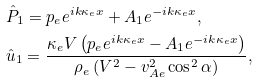<formula> <loc_0><loc_0><loc_500><loc_500>& \hat { P } _ { 1 } = p _ { e } e ^ { i k \kappa _ { e } x } + A _ { 1 } e ^ { - i k \kappa _ { e } x } , \\ & \hat { u } _ { 1 } = \frac { \kappa _ { e } V \left ( p _ { e } e ^ { i k \kappa _ { e } x } - A _ { 1 } e ^ { - i k \kappa _ { e } x } \right ) } { \rho _ { e } \left ( V ^ { 2 } - v _ { A e } ^ { 2 } \cos ^ { 2 } \alpha \right ) } ,</formula> 